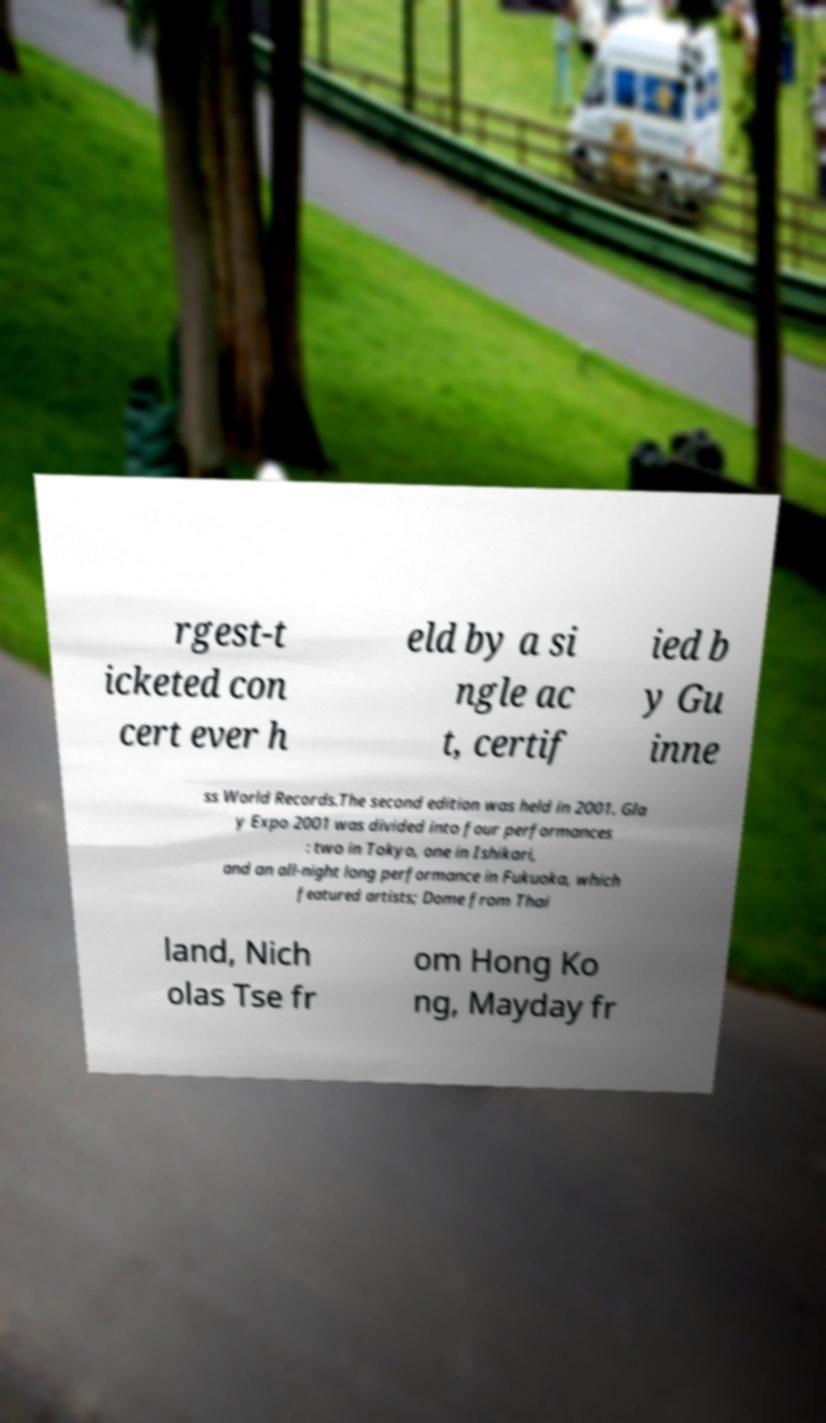Could you assist in decoding the text presented in this image and type it out clearly? rgest-t icketed con cert ever h eld by a si ngle ac t, certif ied b y Gu inne ss World Records.The second edition was held in 2001. Gla y Expo 2001 was divided into four performances : two in Tokyo, one in Ishikari, and an all-night long performance in Fukuoka, which featured artists; Dome from Thai land, Nich olas Tse fr om Hong Ko ng, Mayday fr 